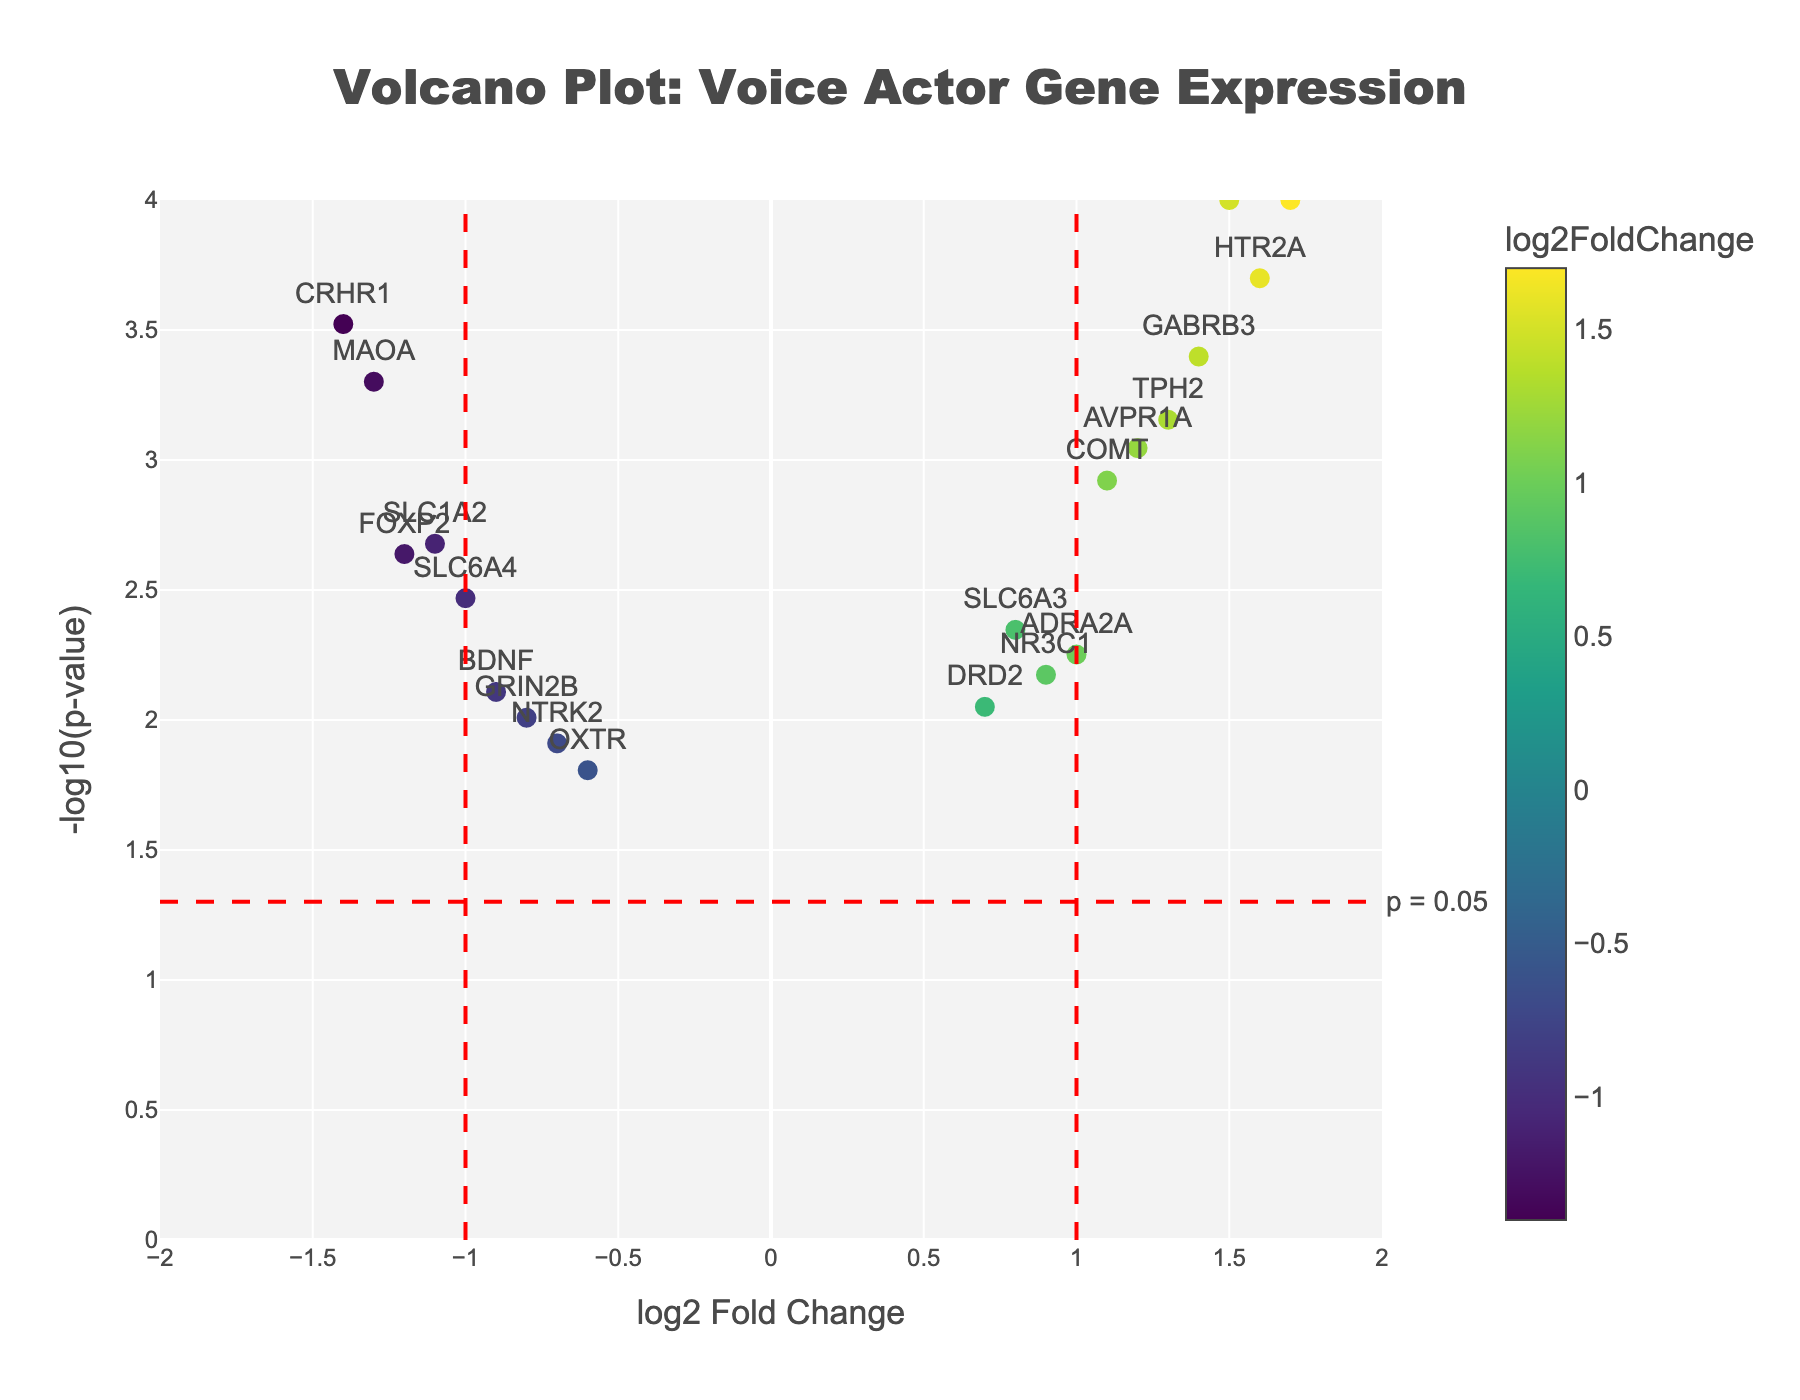What is the title of the plot? The title is located at the top center of the plot. It reads "Volcano Plot: Voice Actor Gene Expression" as specified in the code.
Answer: Volcano Plot: Voice Actor Gene Expression How many genes have a log2 fold change greater than 1? Locate the x-axis labeled "log2 Fold Change." Identify data points to the right of the x=1 line. Count these points.
Answer: 6 Which gene has the most significant p-value? The most significant p-value corresponds to the highest -log10(p-value) on the y-axis. Look for the data point with the highest y-coordinate and note its gene label.
Answer: CACNA1C What is the log2 fold change for the gene with the highest -log10(p-value)? Find the gene with the highest -log10(p-value), which is CACNA1C. Check the x-coordinate (log2 fold change) of this point.
Answer: 1.5 Which gene has a -log10(p-value) closest to 1? Look along the y-axis for -log10(p-value) values near 1 and identify the corresponding gene label.
Answer: OXTR How many genes are upregulated (log2 fold change > 0) and have a -log10(p-value) greater than 2? Identify points with x-coordinates (log2 fold change) greater than 0 and y-coordinates (-log10(p-value)) greater than 2. Count these points.
Answer: 7 Which gene shows the largest decrease in expression (most negative log2 fold change)? Locate the point with the lowest x-coordinate (most negative log2 fold change) and identify the gene label.
Answer: CRHR1 Compare the expression changes of HTR2A and OXTR. Which has a more significant change? Locate HTR2A and OXTR on the plot. Compare their -log10(p-value) values (y-coordinates). The gene with the higher value has a more significant change.
Answer: HTR2A How many genes are present in the bottom right quadrant of the plot (log2 fold change > 1 and -log10(p-value) < 1.3)? Identify the bottom right quadrant by setting conditions on the x and y coordinates. Count data points that meet the criteria.
Answer: 0 